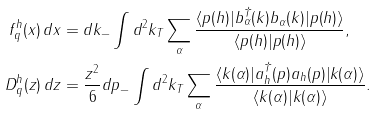<formula> <loc_0><loc_0><loc_500><loc_500>f _ { q } ^ { h } ( x ) \, d x & = d k _ { - } \int d ^ { 2 } k _ { T } \sum _ { \alpha } \frac { \langle p ( h ) | b ^ { \dagger } _ { \alpha } ( k ) b _ { \alpha } ( k ) | p ( h ) \rangle } { \langle p ( h ) | p ( h ) \rangle } , \\ D _ { q } ^ { h } ( z ) \, d z & = \frac { z ^ { 2 } } { 6 } d p _ { - } \int d ^ { 2 } k _ { T } \sum _ { \alpha } \frac { \langle k ( \alpha ) | a ^ { \dagger } _ { h } ( p ) a _ { h } ( p ) | k ( \alpha ) \rangle } { \langle k ( \alpha ) | k ( \alpha ) \rangle } .</formula> 